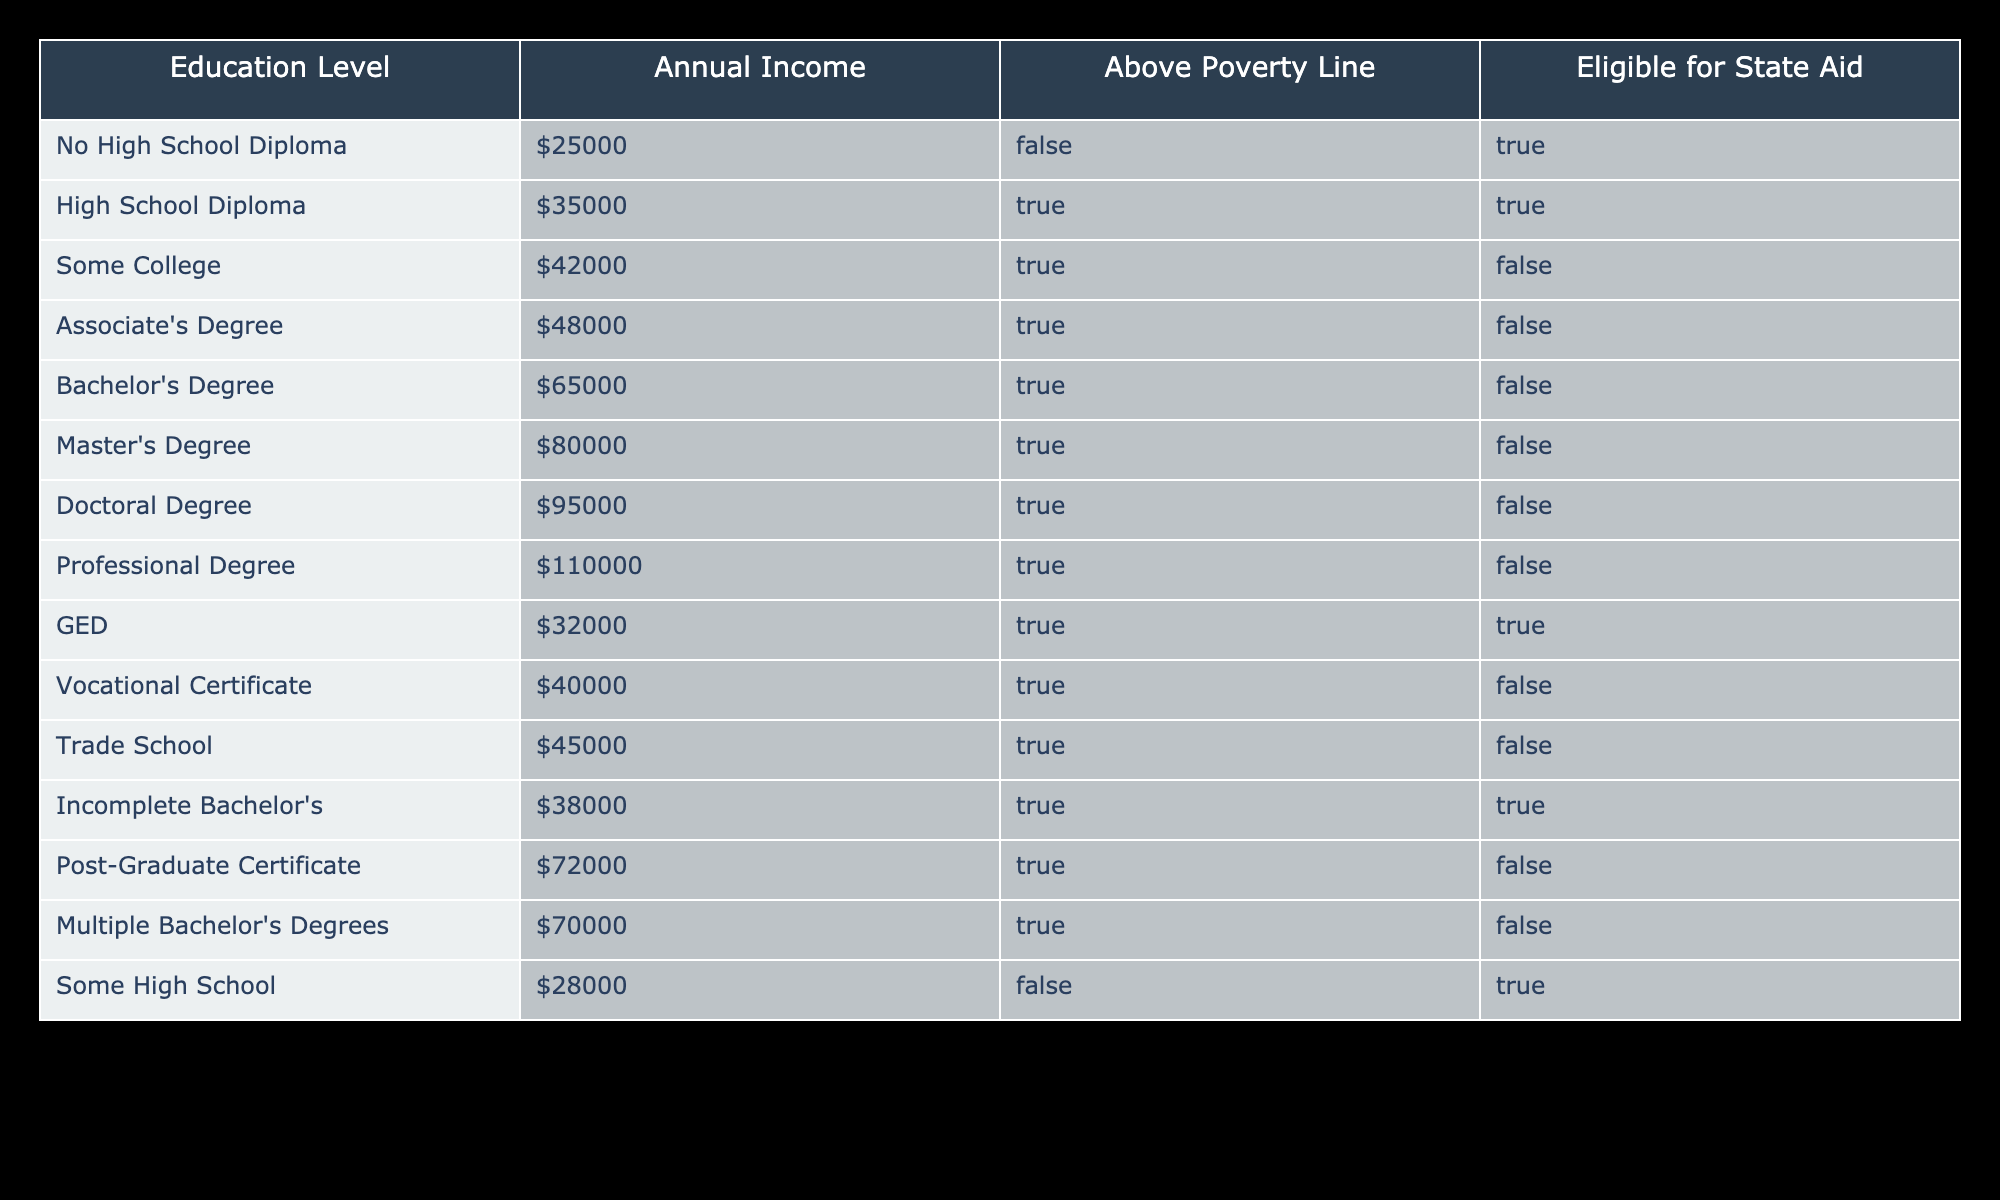What is the annual income for someone with a Doctoral Degree? The row corresponding to the Doctoral Degree shows an annual income value, which is directly stated in the table.
Answer: $95000 What percentage of people with a Bachelor's Degree are above the poverty line? The table shows that all individuals with a Bachelor's Degree are above the poverty line. Since there is only one entry, the percentage is 100%.
Answer: 100% Is someone with a Vocational Certificate eligible for state aid? The table indicates the eligibility for state aid for those with a Vocational Certificate is marked as false.
Answer: No What is the difference in annual income between someone with a Master's Degree and someone with a High School Diploma? The annual income for a Master's Degree is $80000, and for a High School Diploma it is $35000. The difference is calculated as $80000 - $35000 = $45000.
Answer: $45000 How many education levels listed have an annual income below $50000? By reviewing the incomes listed, we find that the levels below $50000 are No High School Diploma ($25000), High School Diploma ($35000), Some College ($42000), Vocational Certificate ($40000), Trade School ($45000), and Incomplete Bachelor's ($38000), resulting in a total of 6 education levels.
Answer: 6 What is the average annual income for those who are above the poverty line? The annual incomes of those above the poverty line are $35000 (High School Diploma), $42000 (Some College), $48000 (Associate's Degree), $65000 (Bachelor's Degree), $80000 (Master's Degree), $95000 (Doctoral Degree), $110000 (Professional Degree), $32000 (GED), $40000 (Vocational Certificate), $45000 (Trade School), $38000 (Incomplete Bachelor's), $72000 (Post-Graduate Certificate), and $70000 (Multiple Bachelor's Degrees). Their total is $745000, divided by the number of entries (12) gives an average of $62083.33.
Answer: $62083.33 Do individuals with a High School Diploma qualify for state aid? Looking at the row for individuals with a High School Diploma in the table, it indicates eligibility for state aid is true.
Answer: Yes Which education level has the highest recorded annual income? In the table, the annual income values are compared and it is found that the highest income is $110000 for those with a Professional Degree.
Answer: Professional Degree 